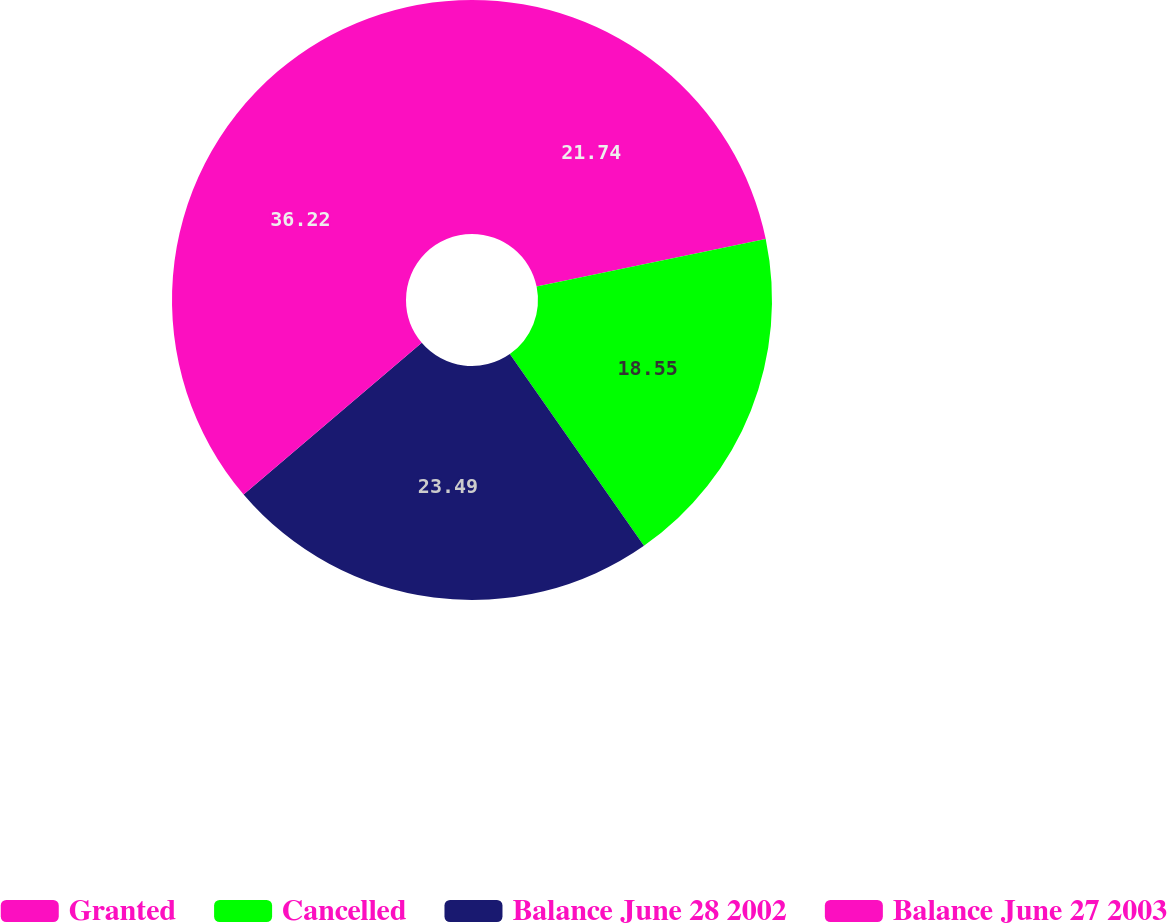Convert chart. <chart><loc_0><loc_0><loc_500><loc_500><pie_chart><fcel>Granted<fcel>Cancelled<fcel>Balance June 28 2002<fcel>Balance June 27 2003<nl><fcel>21.74%<fcel>18.55%<fcel>23.49%<fcel>36.23%<nl></chart> 